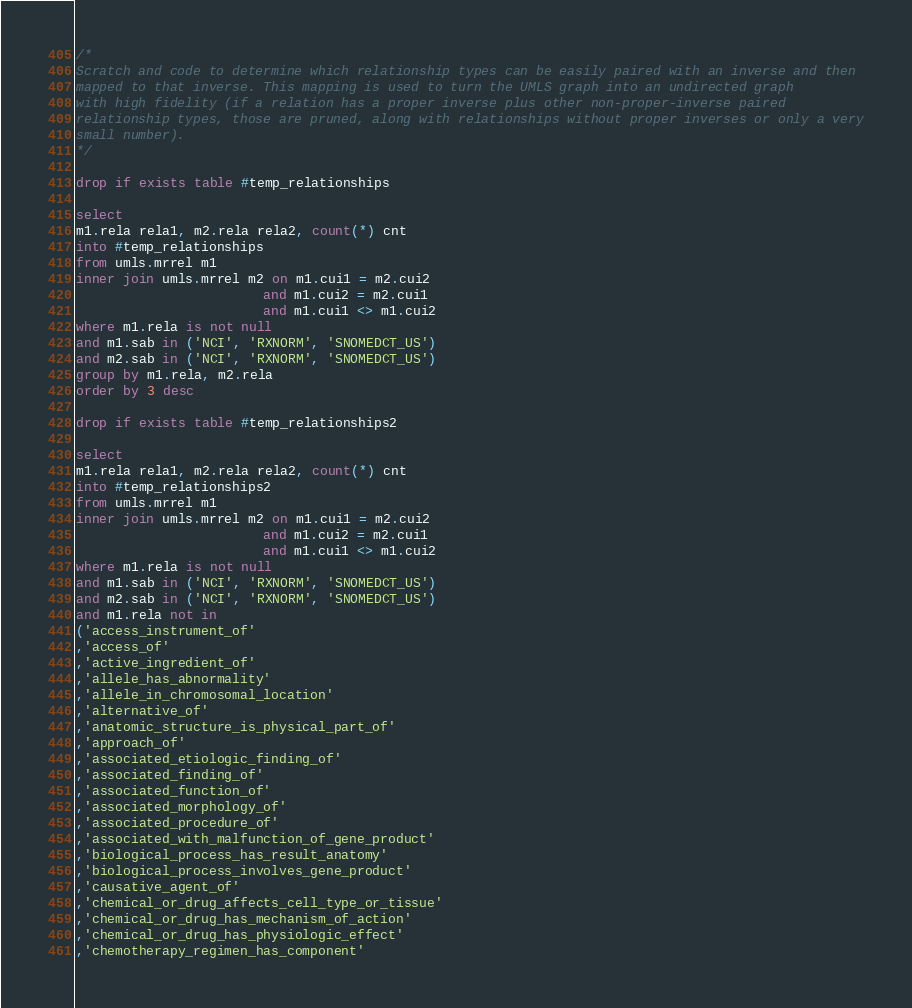Convert code to text. <code><loc_0><loc_0><loc_500><loc_500><_SQL_>
/*
Scratch and code to determine which relationship types can be easily paired with an inverse and then
mapped to that inverse. This mapping is used to turn the UMLS graph into an undirected graph
with high fidelity (if a relation has a proper inverse plus other non-proper-inverse paired
relationship types, those are pruned, along with relationships without proper inverses or only a very
small number).
*/

drop if exists table #temp_relationships

select 
m1.rela rela1, m2.rela rela2, count(*) cnt
into #temp_relationships
from umls.mrrel m1
inner join umls.mrrel m2 on m1.cui1 = m2.cui2
						and m1.cui2 = m2.cui1
						and m1.cui1 <> m1.cui2
where m1.rela is not null
and m1.sab in ('NCI', 'RXNORM', 'SNOMEDCT_US')
and m2.sab in ('NCI', 'RXNORM', 'SNOMEDCT_US')
group by m1.rela, m2.rela
order by 3 desc

drop if exists table #temp_relationships2

select 
m1.rela rela1, m2.rela rela2, count(*) cnt
into #temp_relationships2
from umls.mrrel m1
inner join umls.mrrel m2 on m1.cui1 = m2.cui2
						and m1.cui2 = m2.cui1
						and m1.cui1 <> m1.cui2
where m1.rela is not null
and m1.sab in ('NCI', 'RXNORM', 'SNOMEDCT_US')
and m2.sab in ('NCI', 'RXNORM', 'SNOMEDCT_US')
and m1.rela not in
('access_instrument_of'
,'access_of'
,'active_ingredient_of'
,'allele_has_abnormality'
,'allele_in_chromosomal_location'
,'alternative_of'
,'anatomic_structure_is_physical_part_of'
,'approach_of'
,'associated_etiologic_finding_of'
,'associated_finding_of'
,'associated_function_of'
,'associated_morphology_of'
,'associated_procedure_of'
,'associated_with_malfunction_of_gene_product'
,'biological_process_has_result_anatomy'
,'biological_process_involves_gene_product'
,'causative_agent_of'
,'chemical_or_drug_affects_cell_type_or_tissue'
,'chemical_or_drug_has_mechanism_of_action'
,'chemical_or_drug_has_physiologic_effect'
,'chemotherapy_regimen_has_component'</code> 